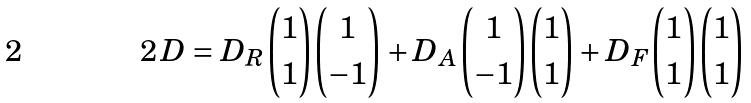<formula> <loc_0><loc_0><loc_500><loc_500>2 \, D = D _ { R } { 1 \choose 1 } { 1 \choose - 1 } + D _ { A } { 1 \choose - 1 } { 1 \choose 1 } + D _ { F } { 1 \choose 1 } { 1 \choose 1 }</formula> 